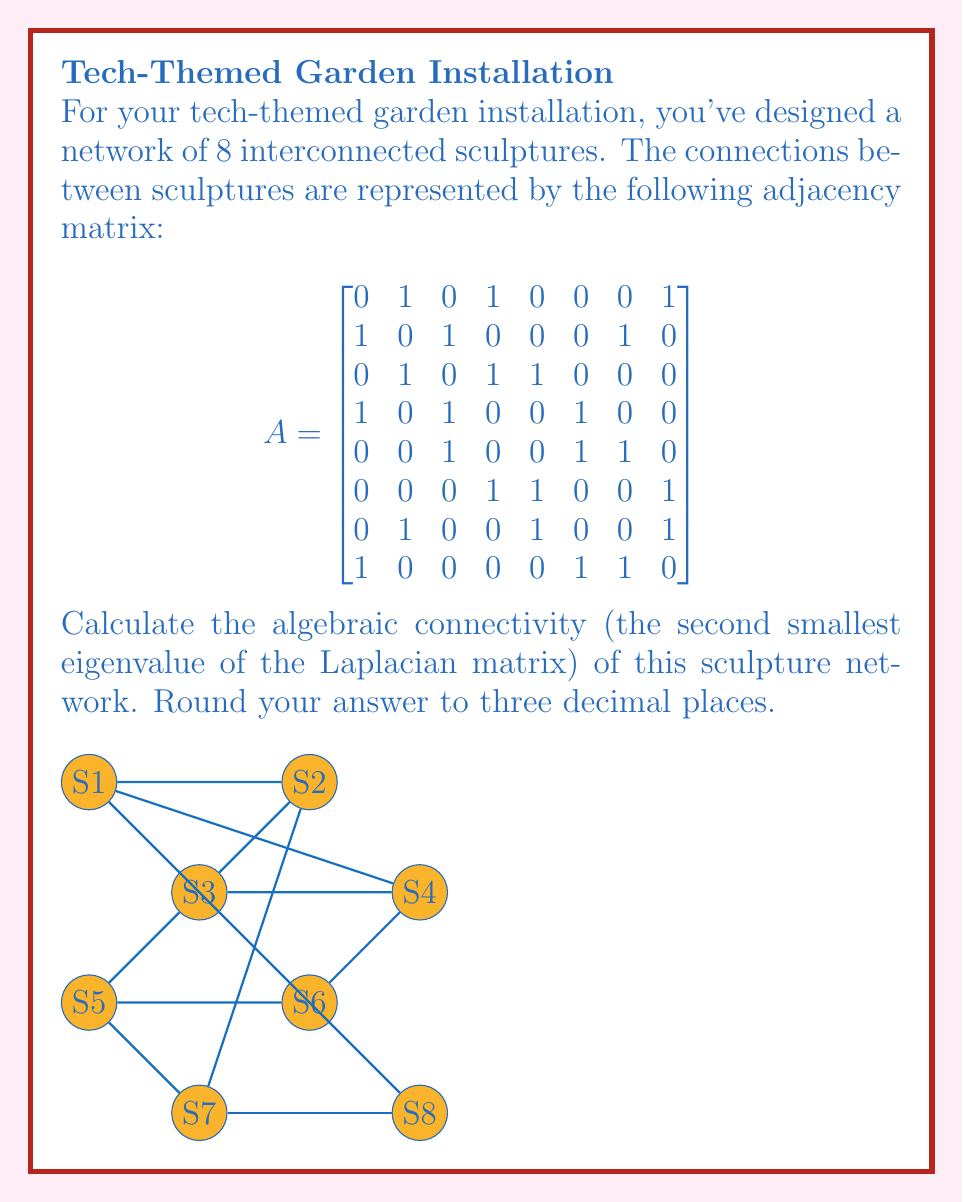Teach me how to tackle this problem. To solve this problem, we'll follow these steps:

1) First, we need to calculate the Laplacian matrix $L$ from the adjacency matrix $A$. The Laplacian matrix is defined as $L = D - A$, where $D$ is the degree matrix.

2) The degree matrix $D$ is a diagonal matrix where $D_{ii}$ is the degree of vertex $i$. We can calculate this by summing each row of $A$:

   $$D = \text{diag}(3, 3, 3, 3, 3, 3, 3, 3)$$

3) Now we can calculate $L$:

   $$
   L = \begin{bmatrix}
   3 & -1 & 0 & -1 & 0 & 0 & 0 & -1 \\
   -1 & 3 & -1 & 0 & 0 & 0 & -1 & 0 \\
   0 & -1 & 3 & -1 & -1 & 0 & 0 & 0 \\
   -1 & 0 & -1 & 3 & 0 & -1 & 0 & 0 \\
   0 & 0 & -1 & 0 & 3 & -1 & -1 & 0 \\
   0 & 0 & 0 & -1 & -1 & 3 & 0 & -1 \\
   0 & -1 & 0 & 0 & -1 & 0 & 3 & -1 \\
   -1 & 0 & 0 & 0 & 0 & -1 & -1 & 3
   \end{bmatrix}
   $$

4) The algebraic connectivity is the second smallest eigenvalue of $L$. To find the eigenvalues, we need to solve the characteristic equation:

   $$\det(L - \lambda I) = 0$$

5) Using a computer algebra system or numerical methods, we can find the eigenvalues:

   $\lambda_1 = 0$
   $\lambda_2 \approx 0.7639$
   $\lambda_3 \approx 1.0000$
   $\lambda_4 \approx 2.0000$
   $\lambda_5 \approx 3.0000$
   $\lambda_6 \approx 3.2361$
   $\lambda_7 \approx 4.0000$
   $\lambda_8 \approx 5.0000$

6) The second smallest eigenvalue (algebraic connectivity) is $\lambda_2 \approx 0.7639$.

7) Rounding to three decimal places, we get 0.764.
Answer: 0.764 